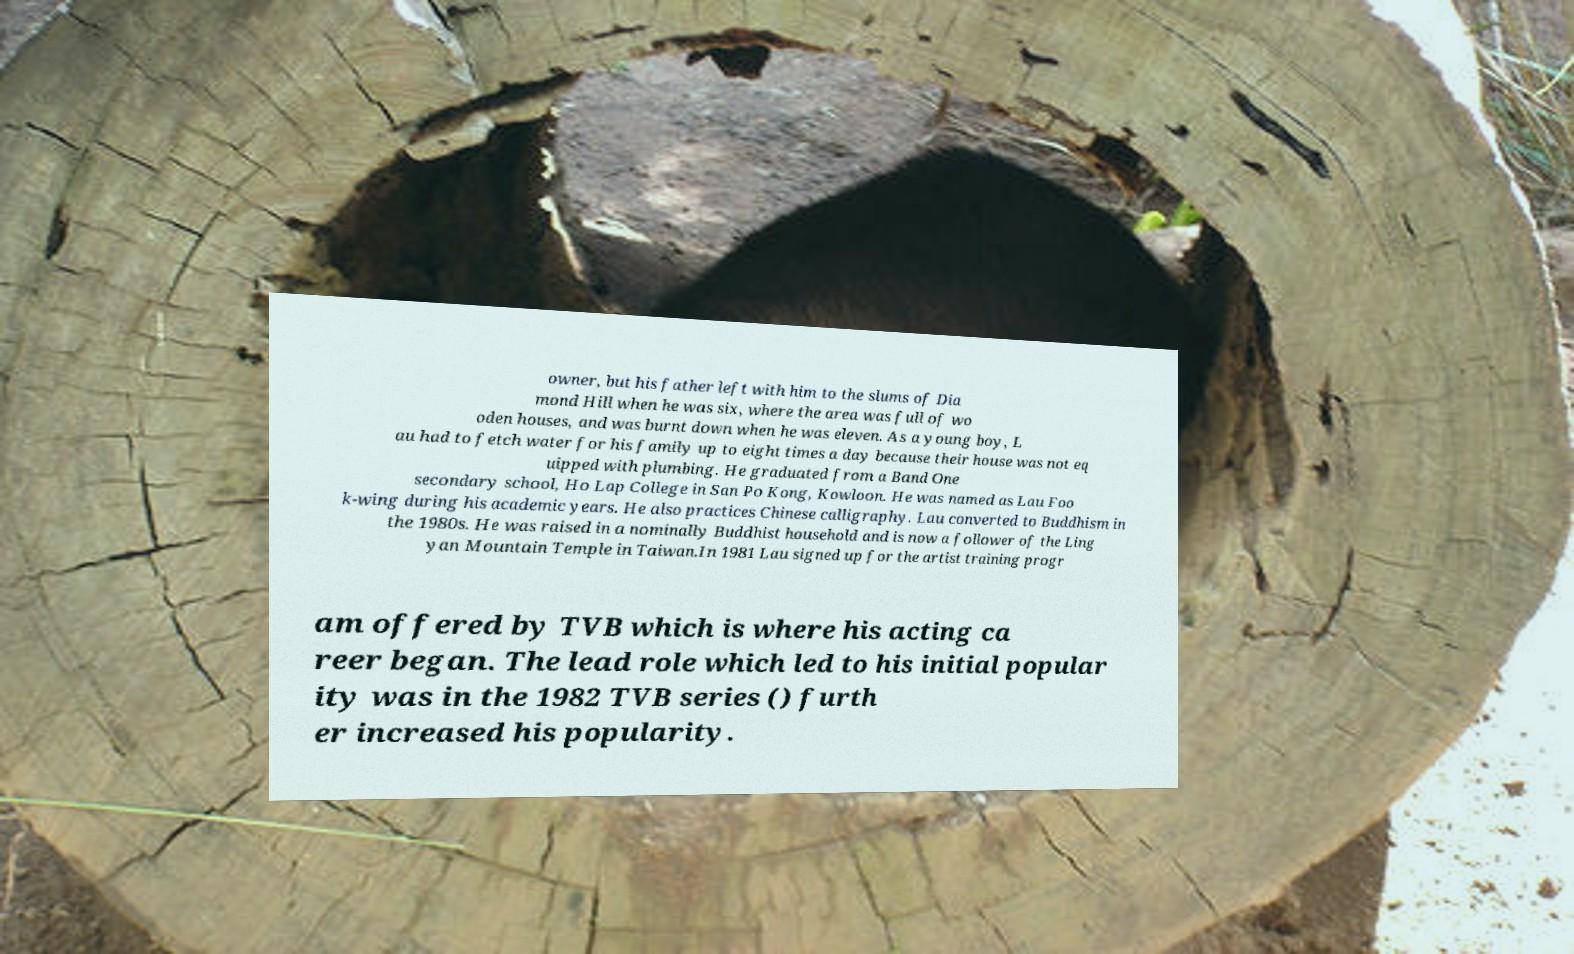Please read and relay the text visible in this image. What does it say? owner, but his father left with him to the slums of Dia mond Hill when he was six, where the area was full of wo oden houses, and was burnt down when he was eleven. As a young boy, L au had to fetch water for his family up to eight times a day because their house was not eq uipped with plumbing. He graduated from a Band One secondary school, Ho Lap College in San Po Kong, Kowloon. He was named as Lau Foo k-wing during his academic years. He also practices Chinese calligraphy. Lau converted to Buddhism in the 1980s. He was raised in a nominally Buddhist household and is now a follower of the Ling yan Mountain Temple in Taiwan.In 1981 Lau signed up for the artist training progr am offered by TVB which is where his acting ca reer began. The lead role which led to his initial popular ity was in the 1982 TVB series () furth er increased his popularity. 